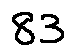<formula> <loc_0><loc_0><loc_500><loc_500>8 3</formula> 